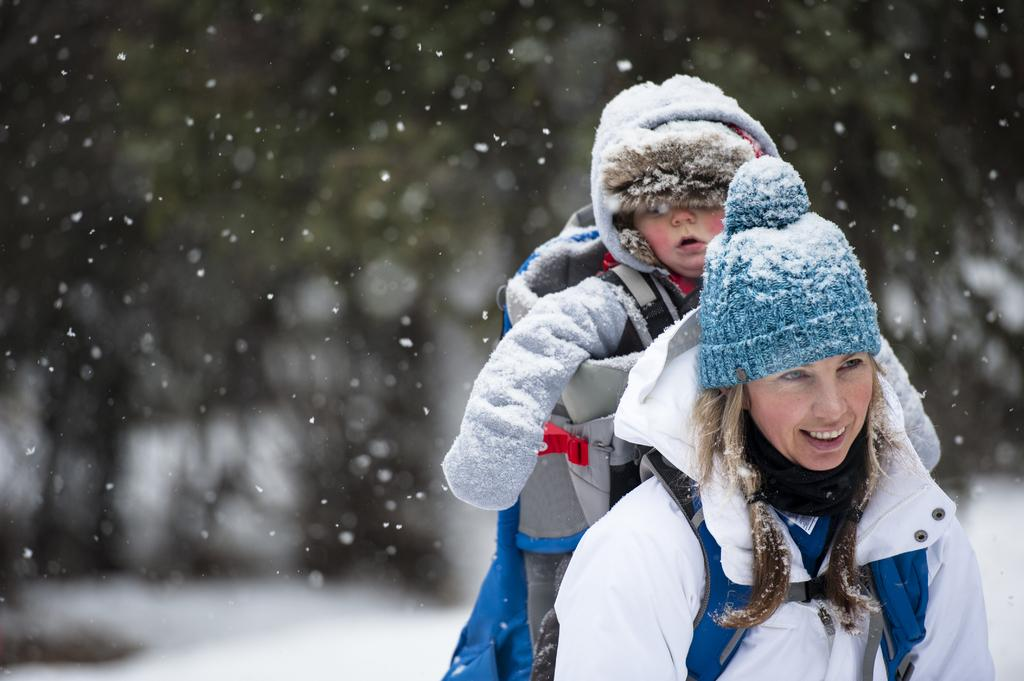Who is the main subject in the image? There is a woman in the image. What is the woman wearing? The woman is wearing a white jacket and a blue cap. What is the woman doing in the image? The woman is carrying a baby in a baby carrier. What is the baby wearing? The baby is wearing a jacket. Can you describe the background of the image? The background of the image is blurry. Where is the playground located in the image? There is no playground present in the image. What type of mist can be seen surrounding the woman and baby? There is no mist present in the image. 